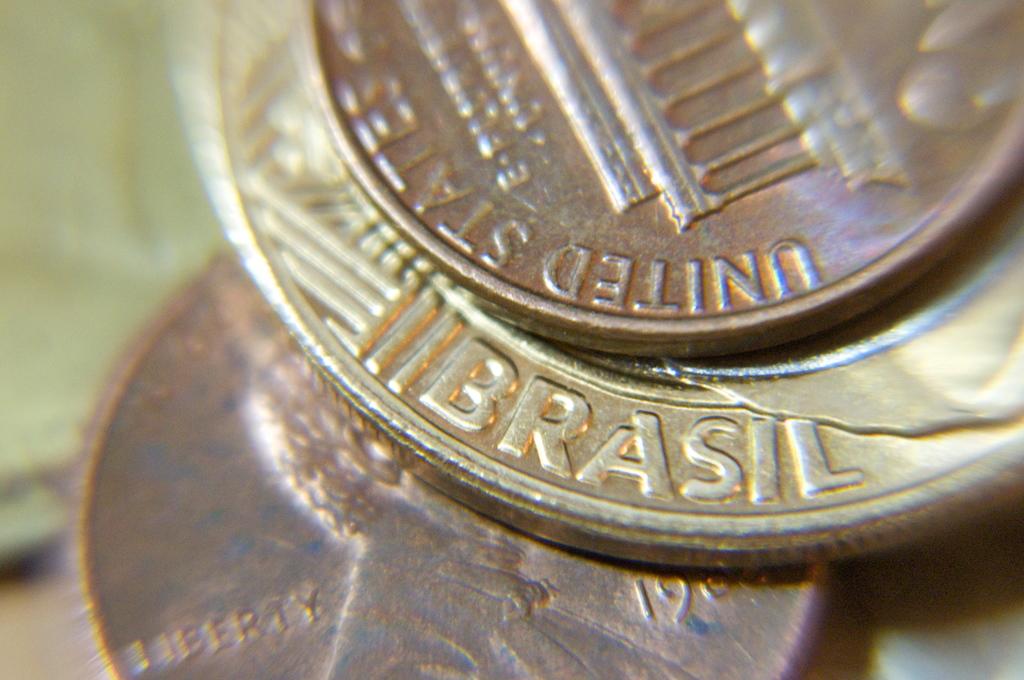What word is on the penny?
Your response must be concise. Liberty. What country is the penny?
Keep it short and to the point. Brasil. 